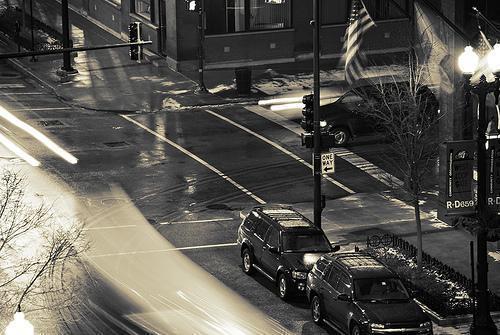What flag can be seen here?
Choose the right answer from the provided options to respond to the question.
Options: France, china, united states, germany. United states. 